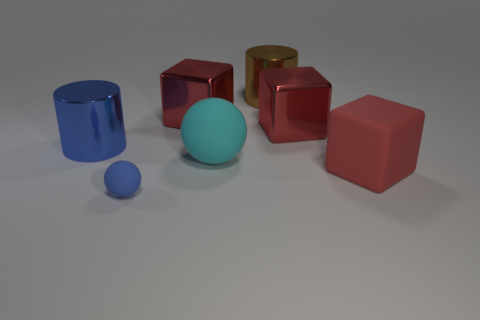Are there any other things that have the same size as the blue rubber object?
Keep it short and to the point. No. There is a cyan rubber thing that is the same shape as the small blue matte thing; what is its size?
Make the answer very short. Large. What shape is the red thing that is both right of the cyan object and behind the cyan object?
Your answer should be compact. Cube. There is a cyan thing; does it have the same size as the red rubber thing that is right of the big cyan matte sphere?
Your answer should be very brief. Yes. What is the color of the other thing that is the same shape as the tiny blue rubber object?
Make the answer very short. Cyan. There is a blue thing that is in front of the red matte cube; is its size the same as the shiny cylinder in front of the brown metal cylinder?
Give a very brief answer. No. Is the cyan thing the same shape as the big blue object?
Offer a terse response. No. What number of things are big red cubes to the left of the large red rubber thing or large matte things?
Your answer should be compact. 4. Is there another object that has the same shape as the tiny blue matte object?
Provide a short and direct response. Yes. Are there the same number of big brown cylinders that are behind the large brown thing and big cyan matte objects?
Provide a succinct answer. No. 